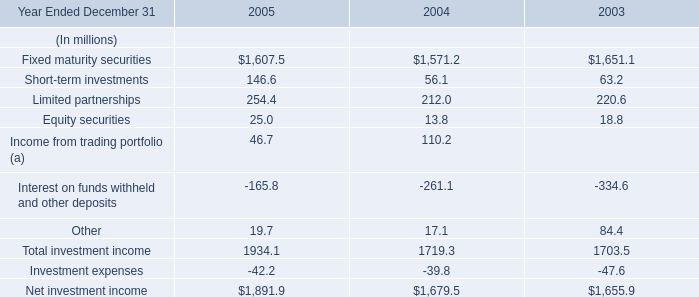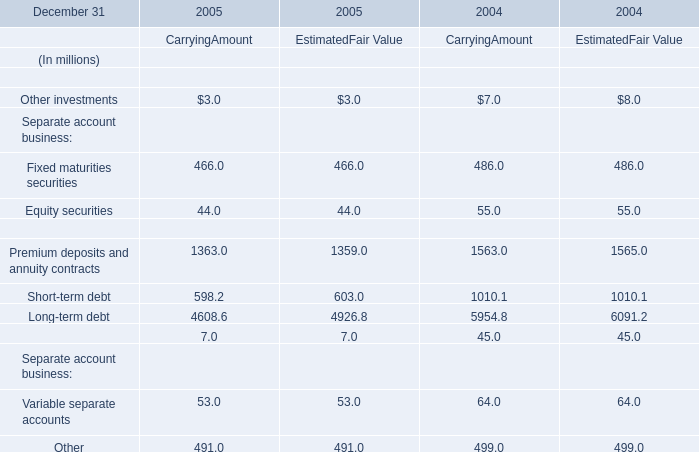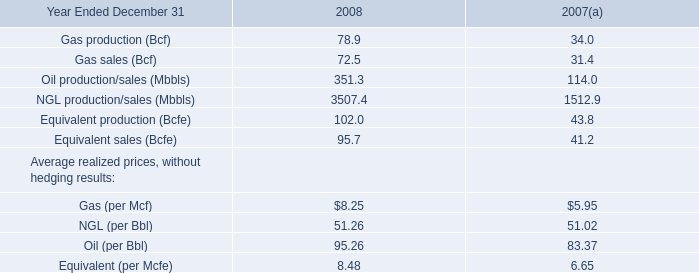What was the total Carrying Amount of Fixed maturities securities, Equity securities, Short-term debt and Long-term debt in 2004? (in million) 
Computations: (((486.0 + 55.0) + 1010.1) + 5954.8)
Answer: 7505.9. 